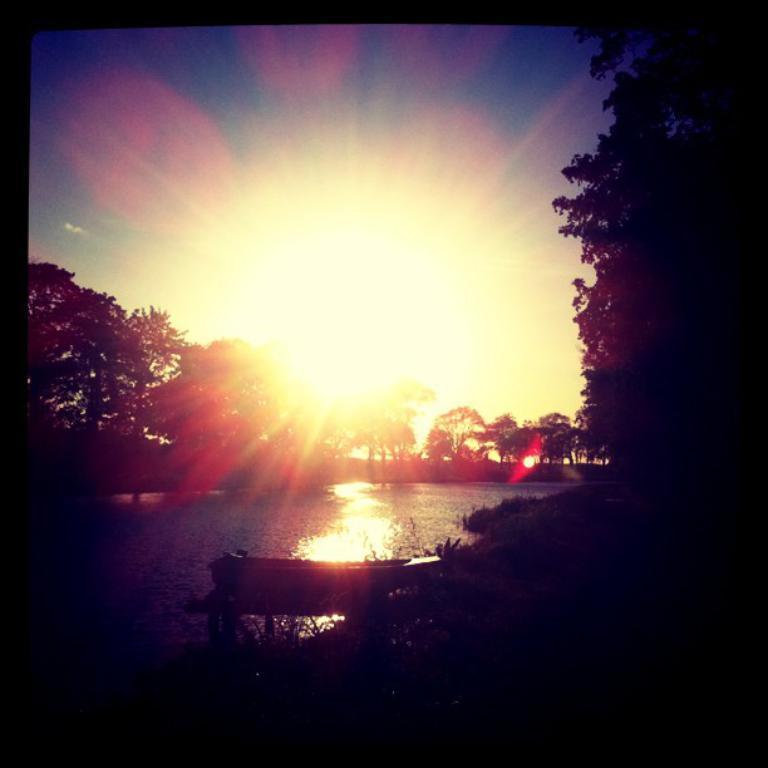Please provide a concise description of this image. In this image in the front there is a tree on the right side and in the background there are trees and there is water in the center and we can see the sun rays which is visible. 